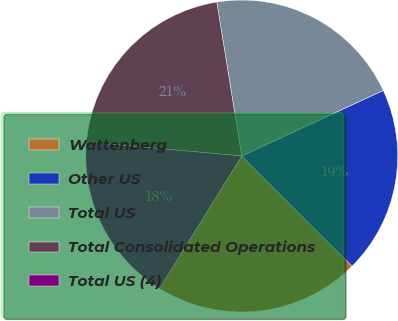Convert chart to OTSL. <chart><loc_0><loc_0><loc_500><loc_500><pie_chart><fcel>Wattenberg<fcel>Other US<fcel>Total US<fcel>Total Consolidated Operations<fcel>Total US (4)<nl><fcel>21.35%<fcel>19.39%<fcel>20.65%<fcel>21.0%<fcel>17.6%<nl></chart> 